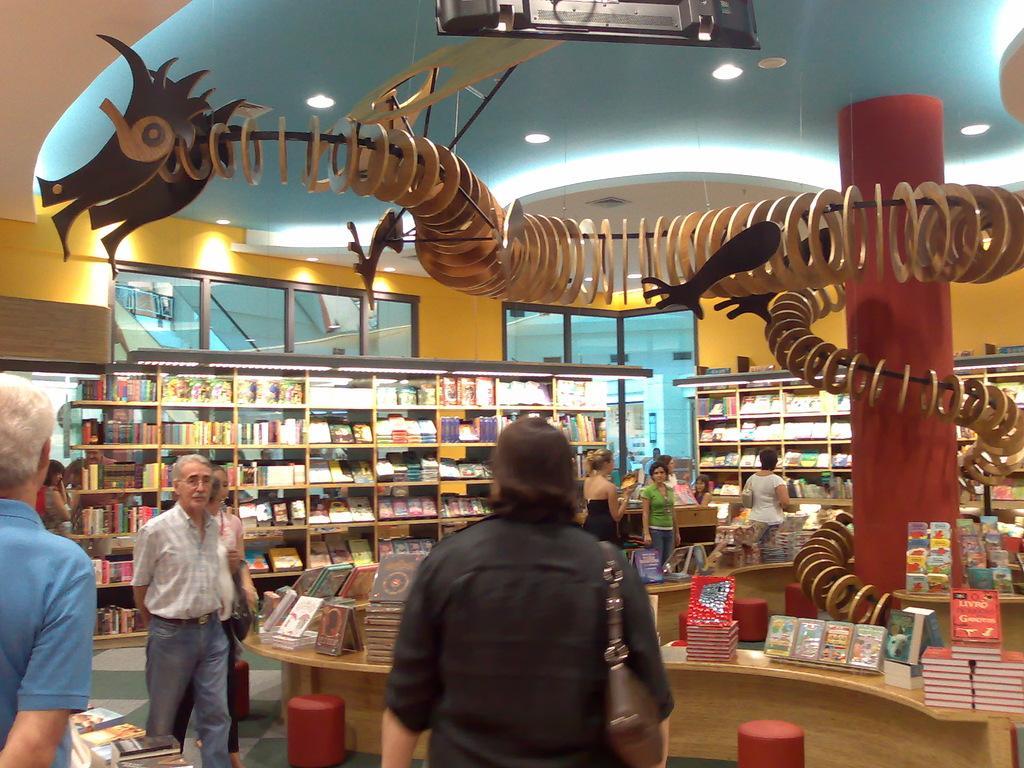Please provide a concise description of this image. In the foreground I can see a group of people are walking on the floor, cabinets on which different types of books, rings, some objects are kept. In the background I can see a pillar, lights on a rooftop, metal rods, cupboards in which different types of books are there, windows and wall. This image is taken may be in a hall. 